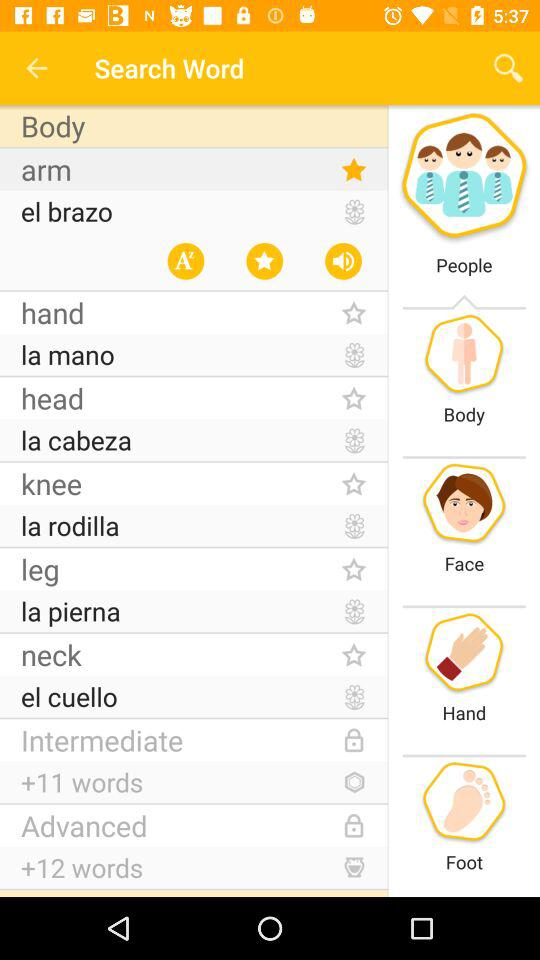How many words are there in "Advanced"? There are 12 words in "Advanced". 